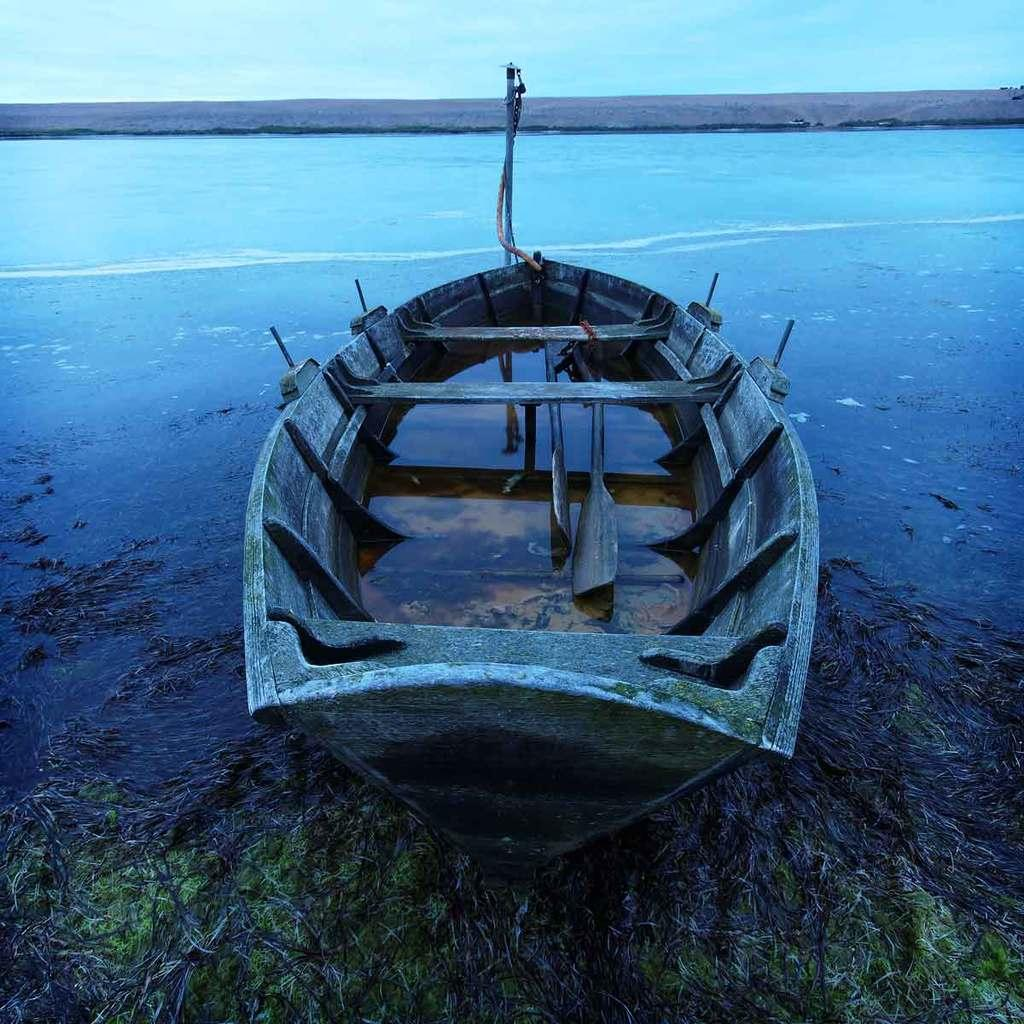What is the main subject of the image? There is a boat in the image. What can be seen in the background of the image? There is water visible in the image. What type of vegetation is present in the image? There are plants and grass in the image. What is the color of the sky in the image? The sky is blue and white in color. Can you see any wounds on the boat in the image? There are no wounds visible on the boat in the image, as boats do not have the ability to experience wounds. 